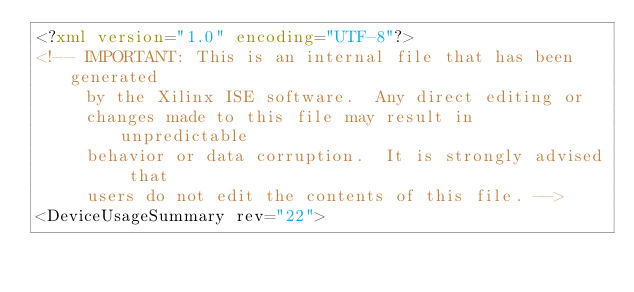<code> <loc_0><loc_0><loc_500><loc_500><_XML_><?xml version="1.0" encoding="UTF-8"?>
<!-- IMPORTANT: This is an internal file that has been generated
     by the Xilinx ISE software.  Any direct editing or
     changes made to this file may result in unpredictable
     behavior or data corruption.  It is strongly advised that
     users do not edit the contents of this file. -->
<DeviceUsageSummary rev="22"></code> 